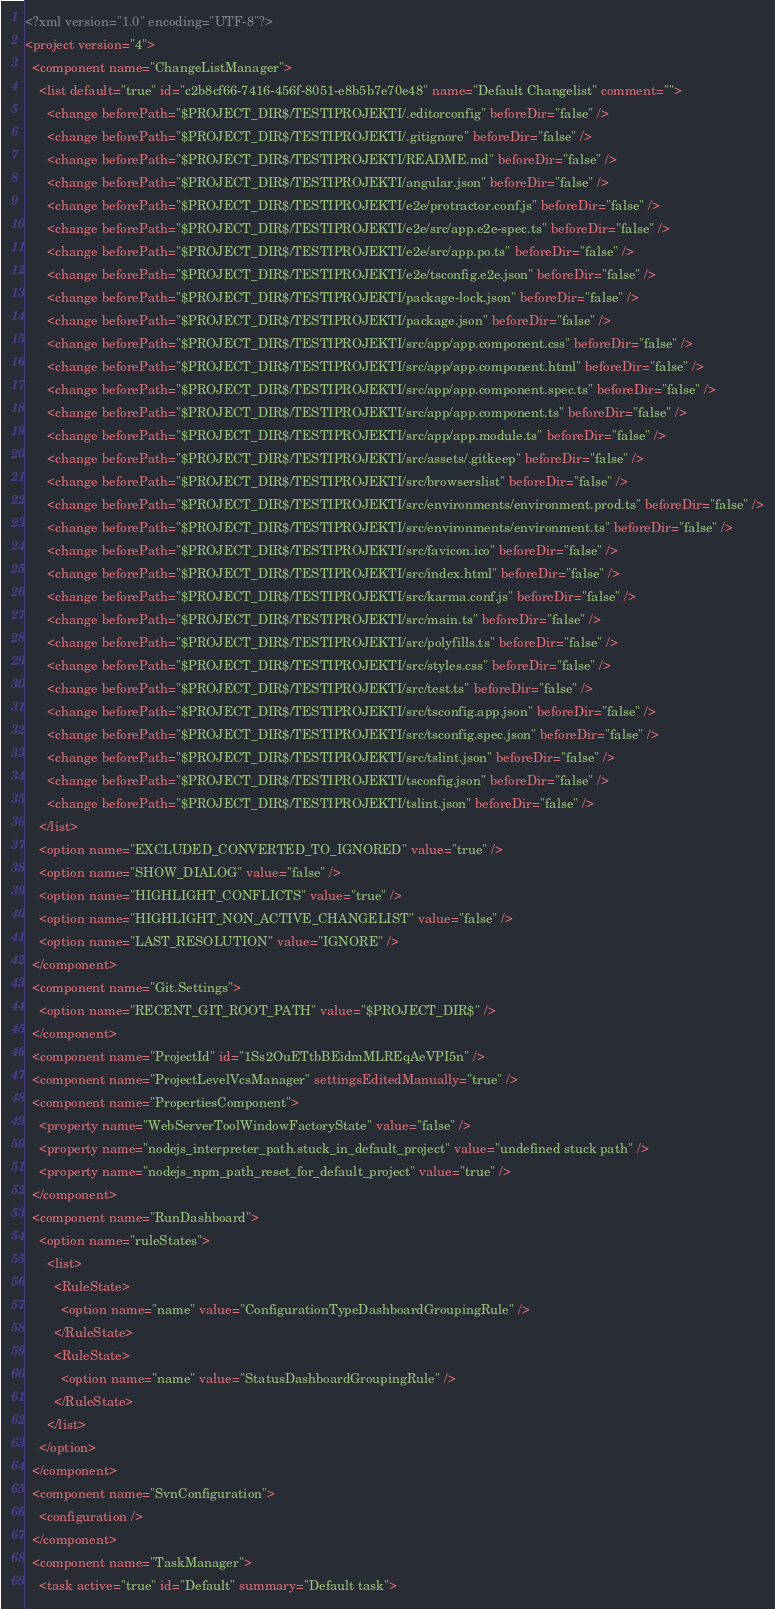<code> <loc_0><loc_0><loc_500><loc_500><_XML_><?xml version="1.0" encoding="UTF-8"?>
<project version="4">
  <component name="ChangeListManager">
    <list default="true" id="c2b8cf66-7416-456f-8051-e8b5b7e70e48" name="Default Changelist" comment="">
      <change beforePath="$PROJECT_DIR$/TESTIPROJEKTI/.editorconfig" beforeDir="false" />
      <change beforePath="$PROJECT_DIR$/TESTIPROJEKTI/.gitignore" beforeDir="false" />
      <change beforePath="$PROJECT_DIR$/TESTIPROJEKTI/README.md" beforeDir="false" />
      <change beforePath="$PROJECT_DIR$/TESTIPROJEKTI/angular.json" beforeDir="false" />
      <change beforePath="$PROJECT_DIR$/TESTIPROJEKTI/e2e/protractor.conf.js" beforeDir="false" />
      <change beforePath="$PROJECT_DIR$/TESTIPROJEKTI/e2e/src/app.e2e-spec.ts" beforeDir="false" />
      <change beforePath="$PROJECT_DIR$/TESTIPROJEKTI/e2e/src/app.po.ts" beforeDir="false" />
      <change beforePath="$PROJECT_DIR$/TESTIPROJEKTI/e2e/tsconfig.e2e.json" beforeDir="false" />
      <change beforePath="$PROJECT_DIR$/TESTIPROJEKTI/package-lock.json" beforeDir="false" />
      <change beforePath="$PROJECT_DIR$/TESTIPROJEKTI/package.json" beforeDir="false" />
      <change beforePath="$PROJECT_DIR$/TESTIPROJEKTI/src/app/app.component.css" beforeDir="false" />
      <change beforePath="$PROJECT_DIR$/TESTIPROJEKTI/src/app/app.component.html" beforeDir="false" />
      <change beforePath="$PROJECT_DIR$/TESTIPROJEKTI/src/app/app.component.spec.ts" beforeDir="false" />
      <change beforePath="$PROJECT_DIR$/TESTIPROJEKTI/src/app/app.component.ts" beforeDir="false" />
      <change beforePath="$PROJECT_DIR$/TESTIPROJEKTI/src/app/app.module.ts" beforeDir="false" />
      <change beforePath="$PROJECT_DIR$/TESTIPROJEKTI/src/assets/.gitkeep" beforeDir="false" />
      <change beforePath="$PROJECT_DIR$/TESTIPROJEKTI/src/browserslist" beforeDir="false" />
      <change beforePath="$PROJECT_DIR$/TESTIPROJEKTI/src/environments/environment.prod.ts" beforeDir="false" />
      <change beforePath="$PROJECT_DIR$/TESTIPROJEKTI/src/environments/environment.ts" beforeDir="false" />
      <change beforePath="$PROJECT_DIR$/TESTIPROJEKTI/src/favicon.ico" beforeDir="false" />
      <change beforePath="$PROJECT_DIR$/TESTIPROJEKTI/src/index.html" beforeDir="false" />
      <change beforePath="$PROJECT_DIR$/TESTIPROJEKTI/src/karma.conf.js" beforeDir="false" />
      <change beforePath="$PROJECT_DIR$/TESTIPROJEKTI/src/main.ts" beforeDir="false" />
      <change beforePath="$PROJECT_DIR$/TESTIPROJEKTI/src/polyfills.ts" beforeDir="false" />
      <change beforePath="$PROJECT_DIR$/TESTIPROJEKTI/src/styles.css" beforeDir="false" />
      <change beforePath="$PROJECT_DIR$/TESTIPROJEKTI/src/test.ts" beforeDir="false" />
      <change beforePath="$PROJECT_DIR$/TESTIPROJEKTI/src/tsconfig.app.json" beforeDir="false" />
      <change beforePath="$PROJECT_DIR$/TESTIPROJEKTI/src/tsconfig.spec.json" beforeDir="false" />
      <change beforePath="$PROJECT_DIR$/TESTIPROJEKTI/src/tslint.json" beforeDir="false" />
      <change beforePath="$PROJECT_DIR$/TESTIPROJEKTI/tsconfig.json" beforeDir="false" />
      <change beforePath="$PROJECT_DIR$/TESTIPROJEKTI/tslint.json" beforeDir="false" />
    </list>
    <option name="EXCLUDED_CONVERTED_TO_IGNORED" value="true" />
    <option name="SHOW_DIALOG" value="false" />
    <option name="HIGHLIGHT_CONFLICTS" value="true" />
    <option name="HIGHLIGHT_NON_ACTIVE_CHANGELIST" value="false" />
    <option name="LAST_RESOLUTION" value="IGNORE" />
  </component>
  <component name="Git.Settings">
    <option name="RECENT_GIT_ROOT_PATH" value="$PROJECT_DIR$" />
  </component>
  <component name="ProjectId" id="1Ss2OuETtbBEidmMLREqAeVPI5n" />
  <component name="ProjectLevelVcsManager" settingsEditedManually="true" />
  <component name="PropertiesComponent">
    <property name="WebServerToolWindowFactoryState" value="false" />
    <property name="nodejs_interpreter_path.stuck_in_default_project" value="undefined stuck path" />
    <property name="nodejs_npm_path_reset_for_default_project" value="true" />
  </component>
  <component name="RunDashboard">
    <option name="ruleStates">
      <list>
        <RuleState>
          <option name="name" value="ConfigurationTypeDashboardGroupingRule" />
        </RuleState>
        <RuleState>
          <option name="name" value="StatusDashboardGroupingRule" />
        </RuleState>
      </list>
    </option>
  </component>
  <component name="SvnConfiguration">
    <configuration />
  </component>
  <component name="TaskManager">
    <task active="true" id="Default" summary="Default task"></code> 